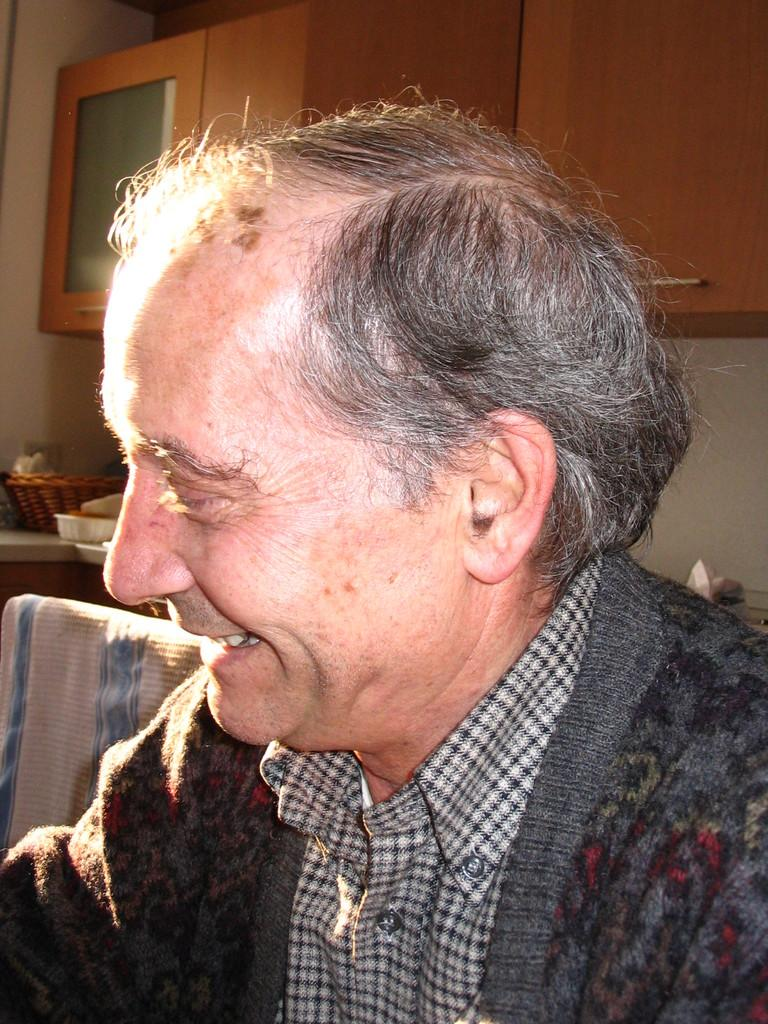Who is present in the image? There is a person in the image. What is the person's expression? The person is smiling. What can be seen in the background of the image? There are baskets of items on a cabinet, cupboards, and a wall in the background. How many women are present in the image, and what are they doing with the needle? There is no mention of women or a needle in the image. The image only features a person who is smiling, and there are baskets of items, cupboards, and a wall in the background. 